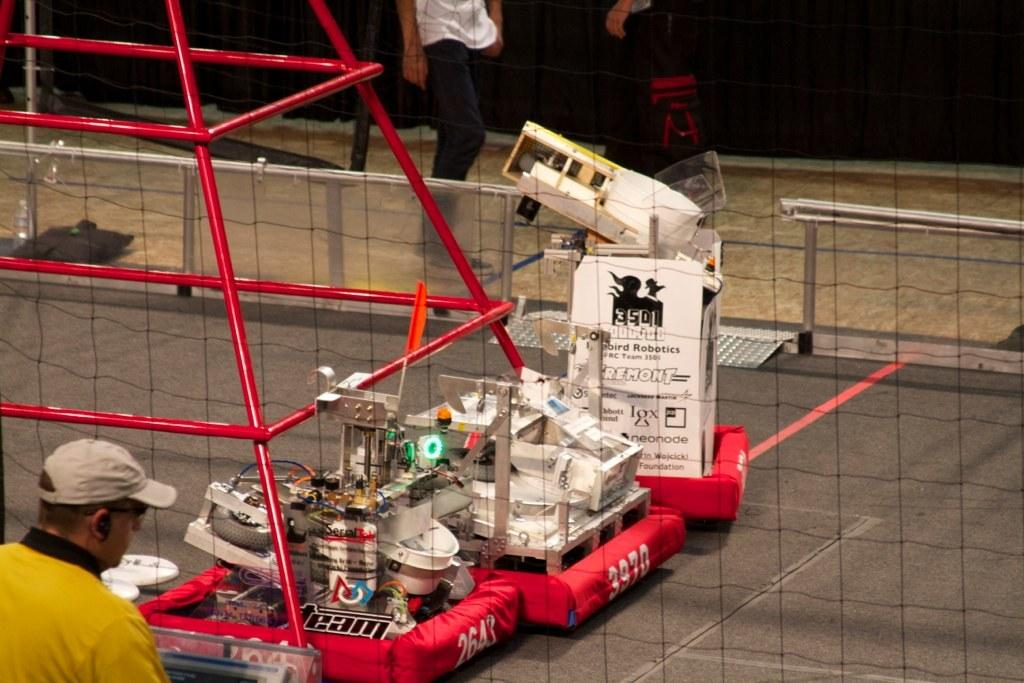Who or what can be seen in the image? There are people in the image. What object is present in the image that is typically used for catching or blocking? There is a net in the image. What type of equipment or devices can be seen in the image? There are machines in the image. Can you describe any other objects or features in the image? There are other unspecified things in the image. What can be seen in the background of the image? There is a fence in the background of the image. What type of flower is growing on the wing of the person in the image? There is no flower or wing present in the image; it features people, a net, machines, and a fence. 